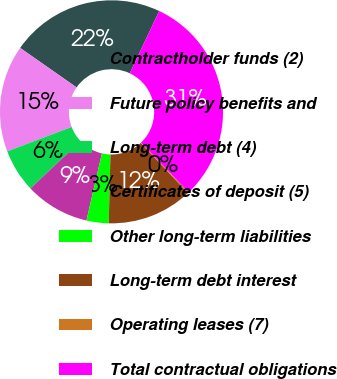<chart> <loc_0><loc_0><loc_500><loc_500><pie_chart><fcel>Contractholder funds (2)<fcel>Future policy benefits and<fcel>Long-term debt (4)<fcel>Certificates of deposit (5)<fcel>Other long-term liabilities<fcel>Long-term debt interest<fcel>Operating leases (7)<fcel>Total contractual obligations<nl><fcel>22.32%<fcel>15.48%<fcel>6.28%<fcel>9.34%<fcel>3.21%<fcel>12.41%<fcel>0.14%<fcel>30.81%<nl></chart> 